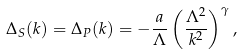<formula> <loc_0><loc_0><loc_500><loc_500>\Delta _ { S } ( k ) = \Delta _ { P } ( k ) = - \frac { a } { \Lambda } \left ( \frac { \Lambda ^ { 2 } } { k ^ { 2 } } \right ) ^ { \gamma } ,</formula> 